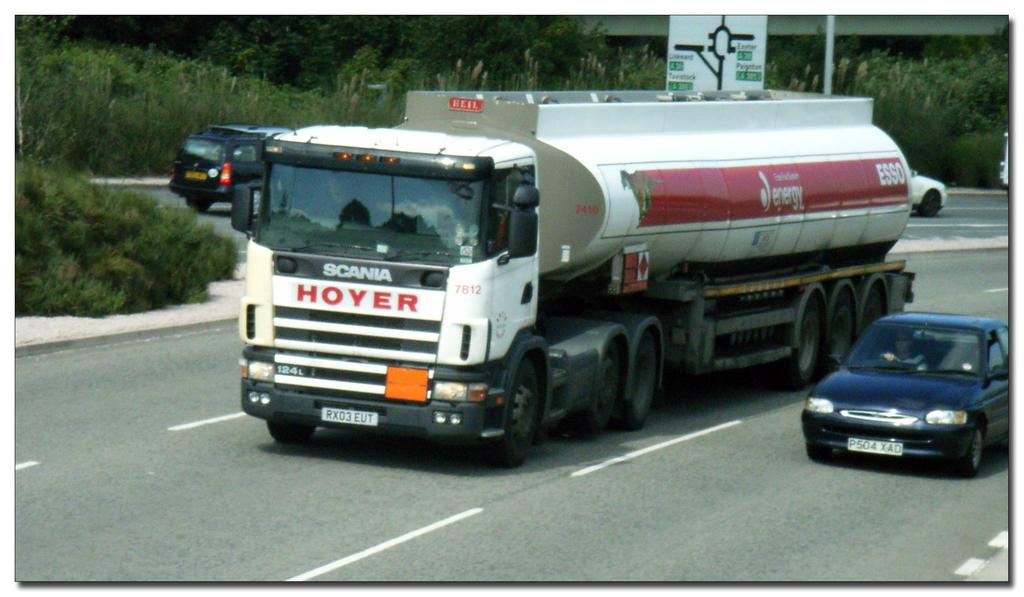What can be seen on the road in the image? There are vehicles on the road in the image. What type of natural elements are visible in the background? There are trees in the background of the image. What man-made structures can be seen in the background? There is a pole, a direction board, and a wall in the background of the image. Can you tell me how many rats are sitting on the direction board in the image? There are no rats present in the image; the direction board is clear of any such creatures. 